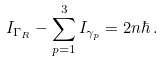<formula> <loc_0><loc_0><loc_500><loc_500>I _ { \Gamma _ { R } } - \sum _ { p = 1 } ^ { 3 } I _ { \gamma _ { p } } = 2 n \hbar { \, } .</formula> 